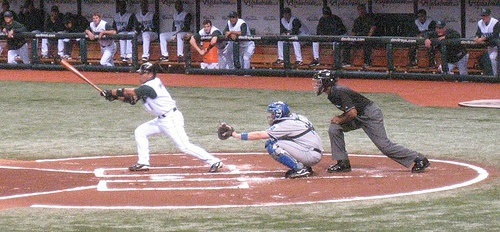Describe the objects in this image and their specific colors. I can see people in gray, black, darkgray, and lavender tones, people in gray, black, and darkgray tones, people in gray, lavender, and darkgray tones, people in gray, white, and darkgray tones, and people in gray, darkgray, and lightpink tones in this image. 